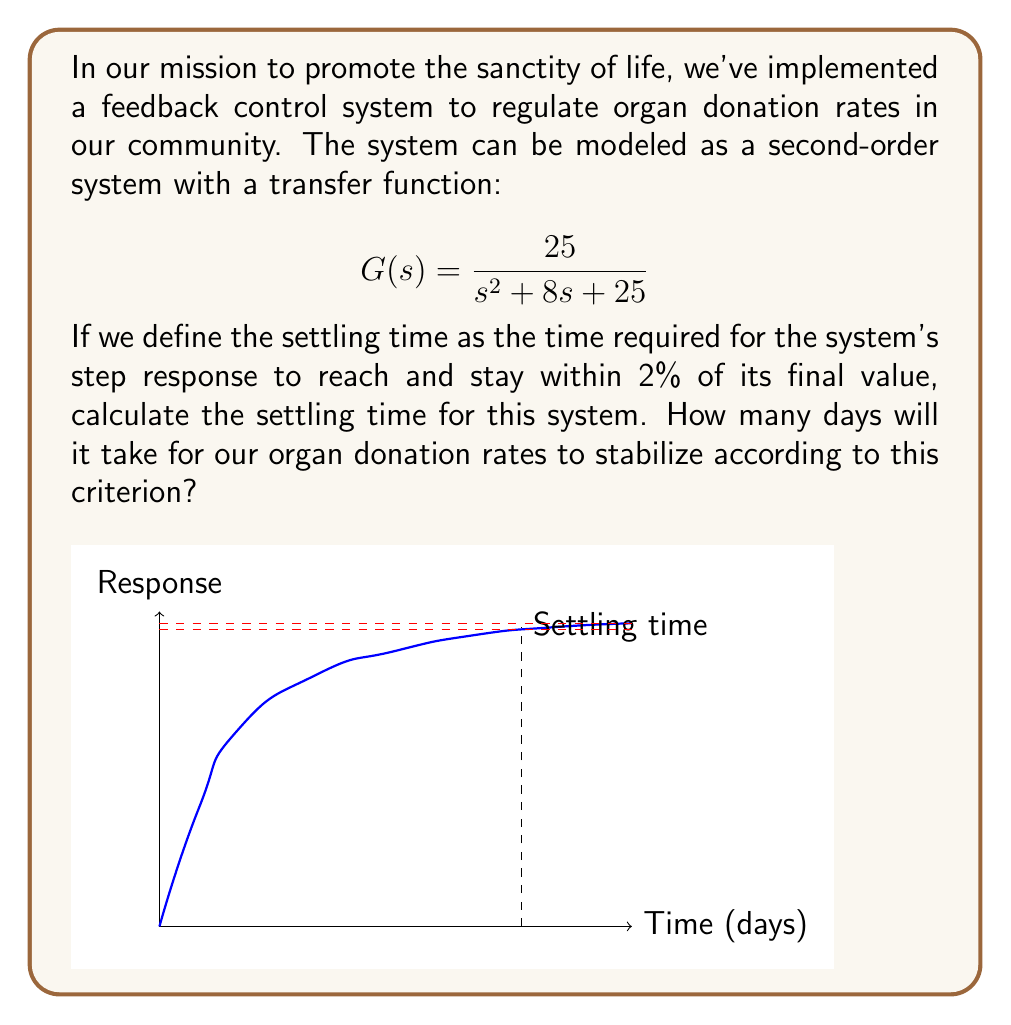Provide a solution to this math problem. To solve this problem, we'll follow these steps:

1) For a second-order system, the settling time $t_s$ is given by the formula:

   $$t_s = \frac{4}{\zeta\omega_n}$$

   where $\zeta$ is the damping ratio and $\omega_n$ is the natural frequency.

2) From the given transfer function:

   $$G(s) = \frac{25}{s^2 + 8s + 25}$$

   We can identify that $\omega_n^2 = 25$ and $2\zeta\omega_n = 8$

3) Calculate $\omega_n$:
   
   $$\omega_n = \sqrt{25} = 5$$

4) Calculate $\zeta$:

   $$2\zeta\omega_n = 8$$
   $$2\zeta(5) = 8$$
   $$\zeta = \frac{8}{10} = 0.8$$

5) Now we can substitute these values into the settling time formula:

   $$t_s = \frac{4}{\zeta\omega_n} = \frac{4}{0.8 \cdot 5} = \frac{4}{4} = 1$$

6) Therefore, the settling time is 1 time unit. Assuming the time unit is in days (as suggested in the question), the settling time is 1 day.

This means that after 1 day, the organ donation rates in our community will have stabilized to within 2% of their final value, allowing us to effectively plan our outreach and support programs.
Answer: 1 day 